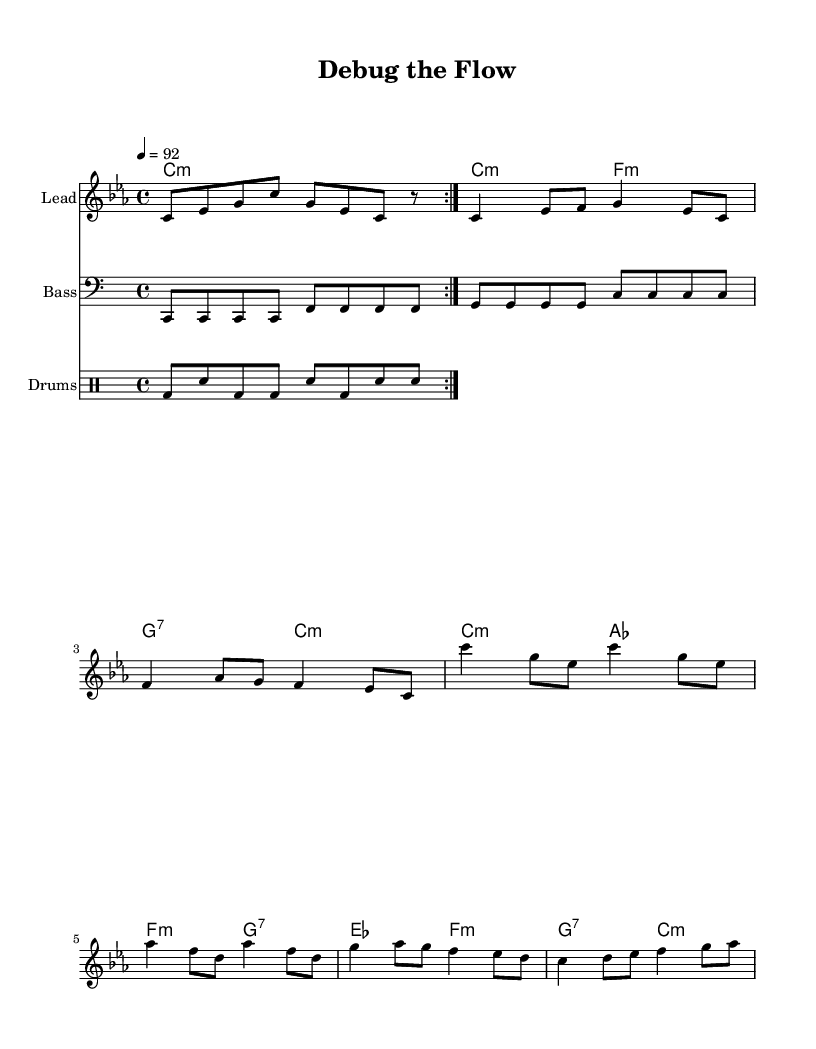What is the key signature of this music? The key signature indicated is C minor, which has three flats (B flat, E flat, and A flat). This can be identified from the global context where it's set at the beginning.
Answer: C minor What is the time signature of this music? The time signature displayed in the global context is 4/4, which means there are four beats in each measure and the quarter note receives one beat. This is noted at the beginning of the score under the global setup.
Answer: 4/4 What is the tempo of this music? The tempo is marked as 92 beats per minute (bpm), indicated within the global context, defining how fast the piece should be played.
Answer: 92 How many verses are there in this song? The song contains one verse as seen in the lyrical structure where only one set of verses is provided before the chorus.
Answer: One verse What is the primary theme expressed in the chorus? The chorus emphasizes the idea of debugging processes and automating workflows, highlighting the need for efficiency. This can be inferred from the lyrics that illustrate these concepts clearly.
Answer: Debugging processes What instrumentation is used for the bass line? The bass line is indicated by a separate staff labeled "Bass," which features lower pitches played throughout the piece. This is typically found in a separate staff designated for bass instruments.
Answer: Bass How is the drum pattern structured in this music? The drum pattern is structured as a repeated volta with a specific arrangement of bass (bd) and snare (sn) hits, indicating a standard rhythmic foundation typical in rap music. This pattern is shown in the drum staff at the end of the score.
Answer: Repeated volta 